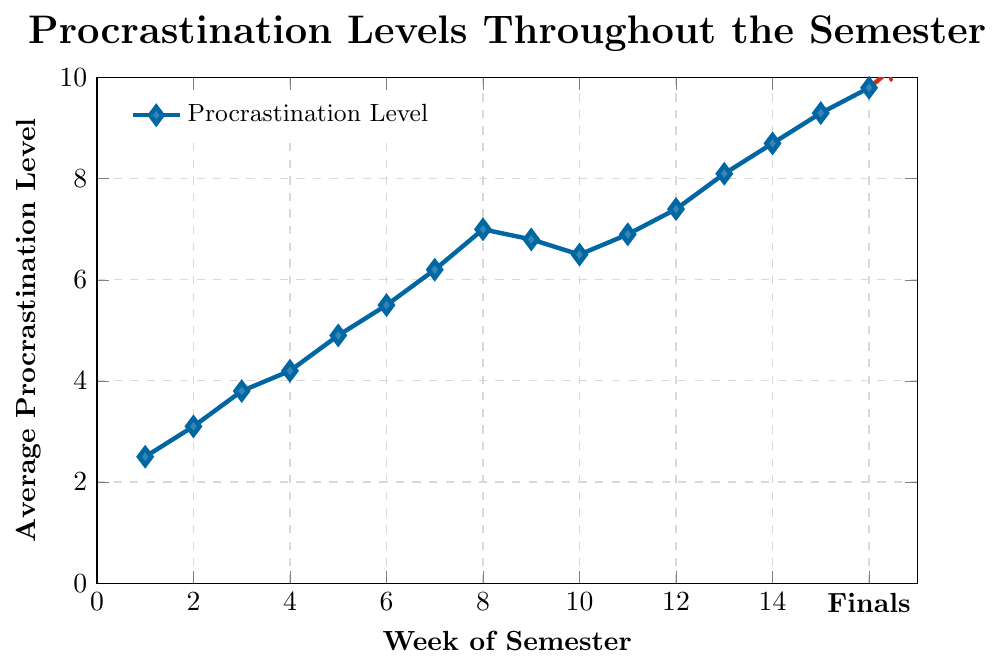How does the procrastination level change from Week 1 to Week 4? The procrastination level in Week 1 is 2.5, and in Week 4 it is 4.2. The difference is 4.2 - 2.5 = 1.7, which means the procrastination level increases by 1.7 units.
Answer: Increases by 1.7 At which week does procrastination level first exceed 5? By examining the data, procrastination first exceeds 5 at Week 6 where the level reaches 5.5.
Answer: Week 6 What is the average procrastination level from Week 11 to Week 14? The data points for Weeks 11 to 14 are 6.9, 7.4, 8.1, and 8.7. The average is (6.9 + 7.4 + 8.1 + 8.7) / 4 = 31.1 / 4 = 7.775.
Answer: 7.775 How much does the procrastination level change between Week 10 and Week 15? The procrastination level in Week 10 is 6.5 and in Week 15 it is 9.3. The change is 9.3 - 6.5 = 2.8.
Answer: 2.8 During which week is the difference between consecutive weeks' procrastination levels the greatest? Calculate the differences: Weeks 7 to 8 = 7.0 - 6.2 = 0.8, Weeks 8 to 9 = 6.8 - 7.0 = -0.2, Weeks 12 to 13 = 8.1 - 7.4 = 0.7. The greatest positive difference is between Weeks 7 to 8 with 0.8.
Answer: Weeks 7 to 8 Compare the procrastination levels at Week 16 (Finals) to the peak level observed during the semester. The peak level observed during the semester is 9.8 at Week 16 (Finals). There is no higher level throughout the semester.
Answer: Week 16 (Finals) is the peak How does the procrastination level change from Week 14 to Week 16? The procrastination level at Week 14 is 8.7 and at Week 16 is 9.8. The difference is 9.8 - 8.7 = 1.1.
Answer: Increases by 1.1 Is there any week when the procrastination level decreases compared to the previous week? If so, identify the week(s). The data shows a decrease from Week 8 (7.0) to Week 9 (6.8) and Week 10 (6.5) to Week 9 (6.8).
Answer: Weeks 9 and 10 What is the trend in procrastination levels from Week 1 to Week 16? The trend line shows that procrastination levels generally increase over the semester, with small fluctuations, peaking at week 16.
Answer: Increasing trend 